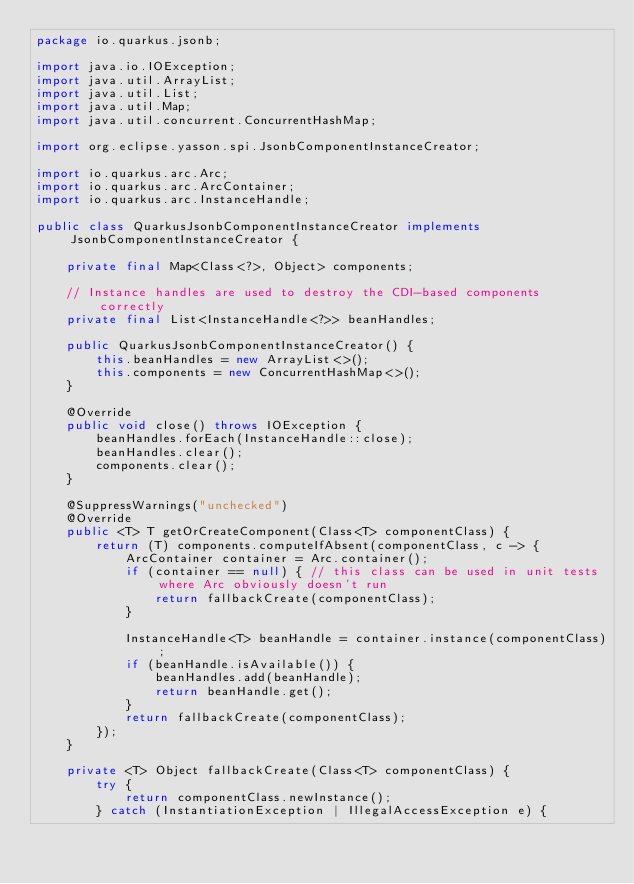Convert code to text. <code><loc_0><loc_0><loc_500><loc_500><_Java_>package io.quarkus.jsonb;

import java.io.IOException;
import java.util.ArrayList;
import java.util.List;
import java.util.Map;
import java.util.concurrent.ConcurrentHashMap;

import org.eclipse.yasson.spi.JsonbComponentInstanceCreator;

import io.quarkus.arc.Arc;
import io.quarkus.arc.ArcContainer;
import io.quarkus.arc.InstanceHandle;

public class QuarkusJsonbComponentInstanceCreator implements JsonbComponentInstanceCreator {

    private final Map<Class<?>, Object> components;

    // Instance handles are used to destroy the CDI-based components correctly
    private final List<InstanceHandle<?>> beanHandles;

    public QuarkusJsonbComponentInstanceCreator() {
        this.beanHandles = new ArrayList<>();
        this.components = new ConcurrentHashMap<>();
    }

    @Override
    public void close() throws IOException {
        beanHandles.forEach(InstanceHandle::close);
        beanHandles.clear();
        components.clear();
    }

    @SuppressWarnings("unchecked")
    @Override
    public <T> T getOrCreateComponent(Class<T> componentClass) {
        return (T) components.computeIfAbsent(componentClass, c -> {
            ArcContainer container = Arc.container();
            if (container == null) { // this class can be used in unit tests where Arc obviously doesn't run
                return fallbackCreate(componentClass);
            }

            InstanceHandle<T> beanHandle = container.instance(componentClass);
            if (beanHandle.isAvailable()) {
                beanHandles.add(beanHandle);
                return beanHandle.get();
            }
            return fallbackCreate(componentClass);
        });
    }

    private <T> Object fallbackCreate(Class<T> componentClass) {
        try {
            return componentClass.newInstance();
        } catch (InstantiationException | IllegalAccessException e) {</code> 